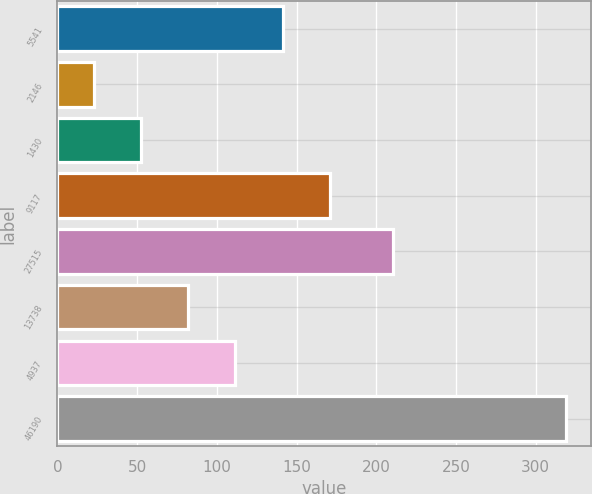Convert chart. <chart><loc_0><loc_0><loc_500><loc_500><bar_chart><fcel>5541<fcel>2146<fcel>1430<fcel>9117<fcel>27515<fcel>13738<fcel>4937<fcel>46190<nl><fcel>141.16<fcel>22.8<fcel>52.39<fcel>170.75<fcel>210.4<fcel>81.98<fcel>111.57<fcel>318.7<nl></chart> 